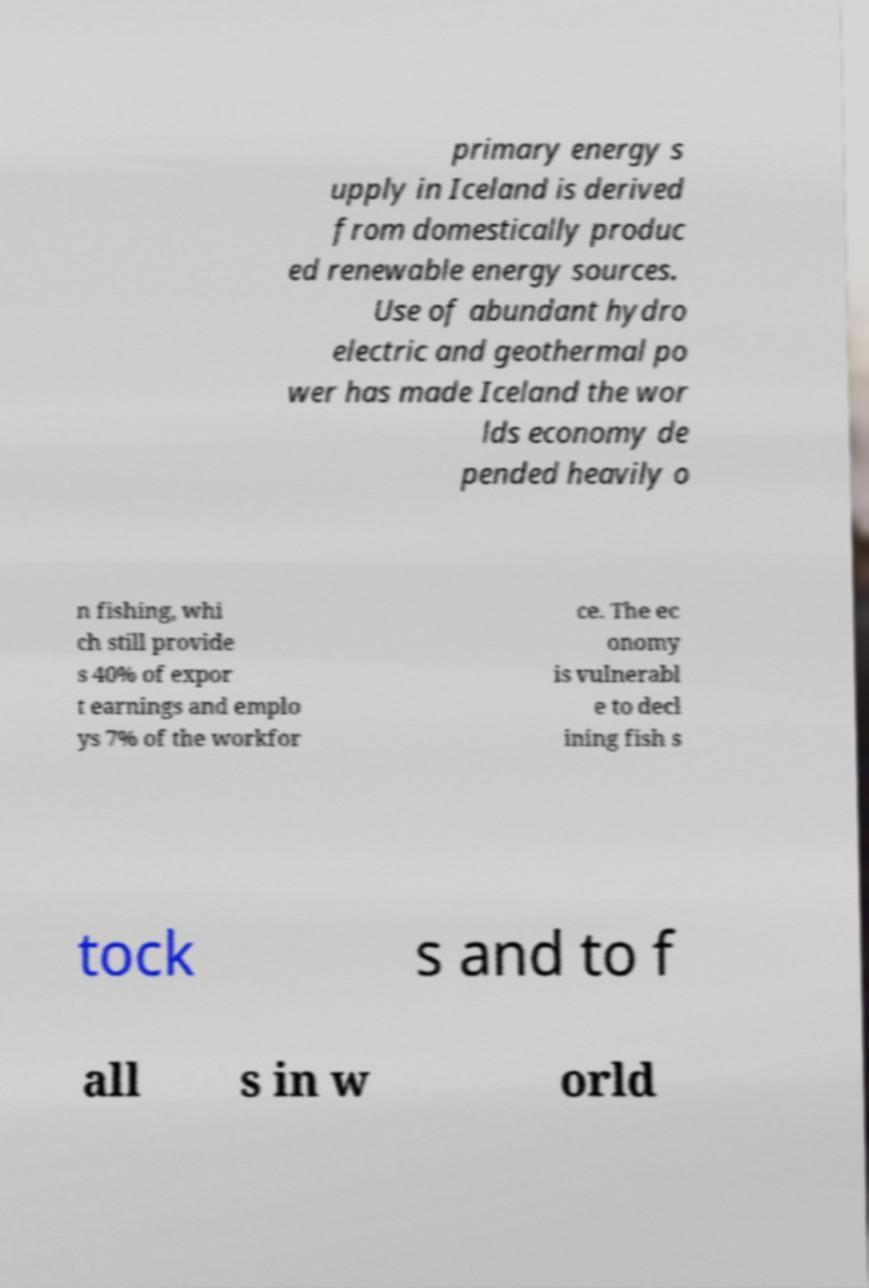What messages or text are displayed in this image? I need them in a readable, typed format. primary energy s upply in Iceland is derived from domestically produc ed renewable energy sources. Use of abundant hydro electric and geothermal po wer has made Iceland the wor lds economy de pended heavily o n fishing, whi ch still provide s 40% of expor t earnings and emplo ys 7% of the workfor ce. The ec onomy is vulnerabl e to decl ining fish s tock s and to f all s in w orld 